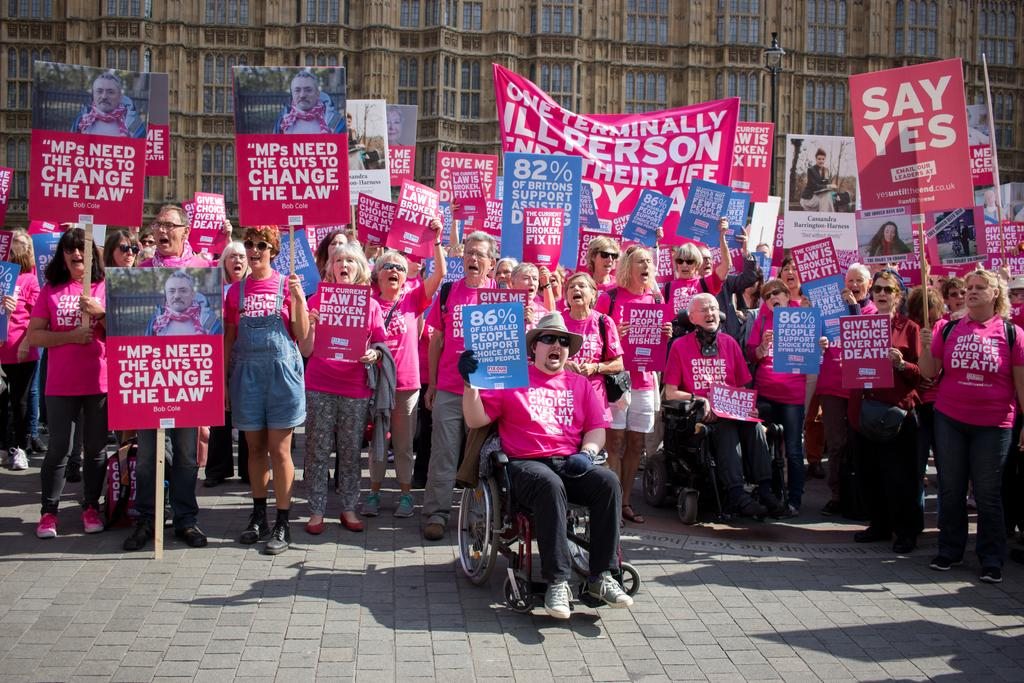What is the main subject of the image? The main subject of the image is a group of people. What are the people in the image doing? Some people are standing, while others are sitting on a wheelchair. They are holding pluck cards and banners. What can be seen in the background of the image? There is a building in the background of the image. What type of board is being used by the people in the image? There is no board present in the image. The people are holding pluck cards and banners, not a board. 